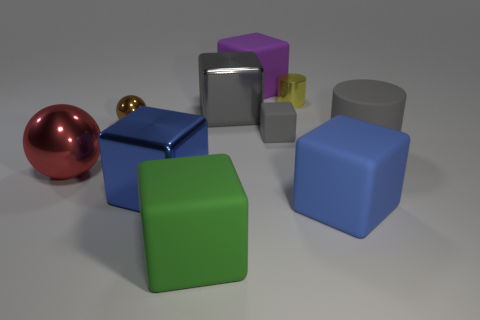What is the color of the cylinder that is the same size as the red thing?
Ensure brevity in your answer.  Gray. How many other things are the same shape as the blue metallic object?
Offer a terse response. 5. Is there a red object that has the same material as the yellow cylinder?
Provide a short and direct response. Yes. Does the large red thing that is in front of the tiny yellow metal object have the same material as the sphere behind the gray rubber cylinder?
Offer a very short reply. Yes. How many large brown matte objects are there?
Offer a very short reply. 0. The tiny shiny thing on the left side of the small gray block has what shape?
Offer a terse response. Sphere. What number of other objects are the same size as the purple block?
Your response must be concise. 6. There is a thing that is in front of the big blue rubber thing; does it have the same shape as the tiny metal object that is to the right of the purple rubber block?
Ensure brevity in your answer.  No. How many yellow shiny cylinders are left of the blue metallic object?
Provide a succinct answer. 0. What color is the shiny thing left of the brown ball?
Your answer should be very brief. Red. 